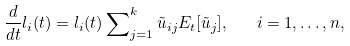<formula> <loc_0><loc_0><loc_500><loc_500>\frac { d } { d t } l _ { i } ( t ) = l _ { i } ( t ) \sum \nolimits _ { j = 1 } ^ { k } \tilde { u } _ { i j } E _ { t } [ \tilde { u } _ { j } ] , \quad i = 1 , \dots , n ,</formula> 